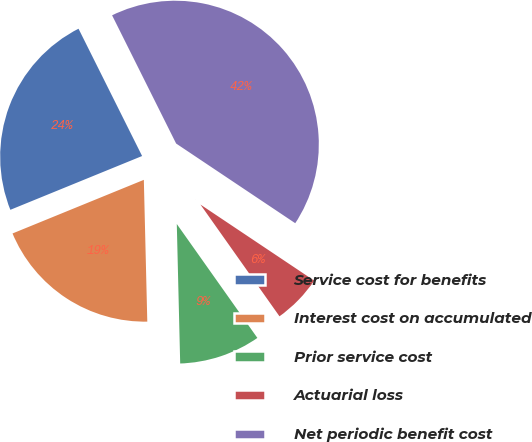Convert chart to OTSL. <chart><loc_0><loc_0><loc_500><loc_500><pie_chart><fcel>Service cost for benefits<fcel>Interest cost on accumulated<fcel>Prior service cost<fcel>Actuarial loss<fcel>Net periodic benefit cost<nl><fcel>23.8%<fcel>19.22%<fcel>9.41%<fcel>5.82%<fcel>41.76%<nl></chart> 